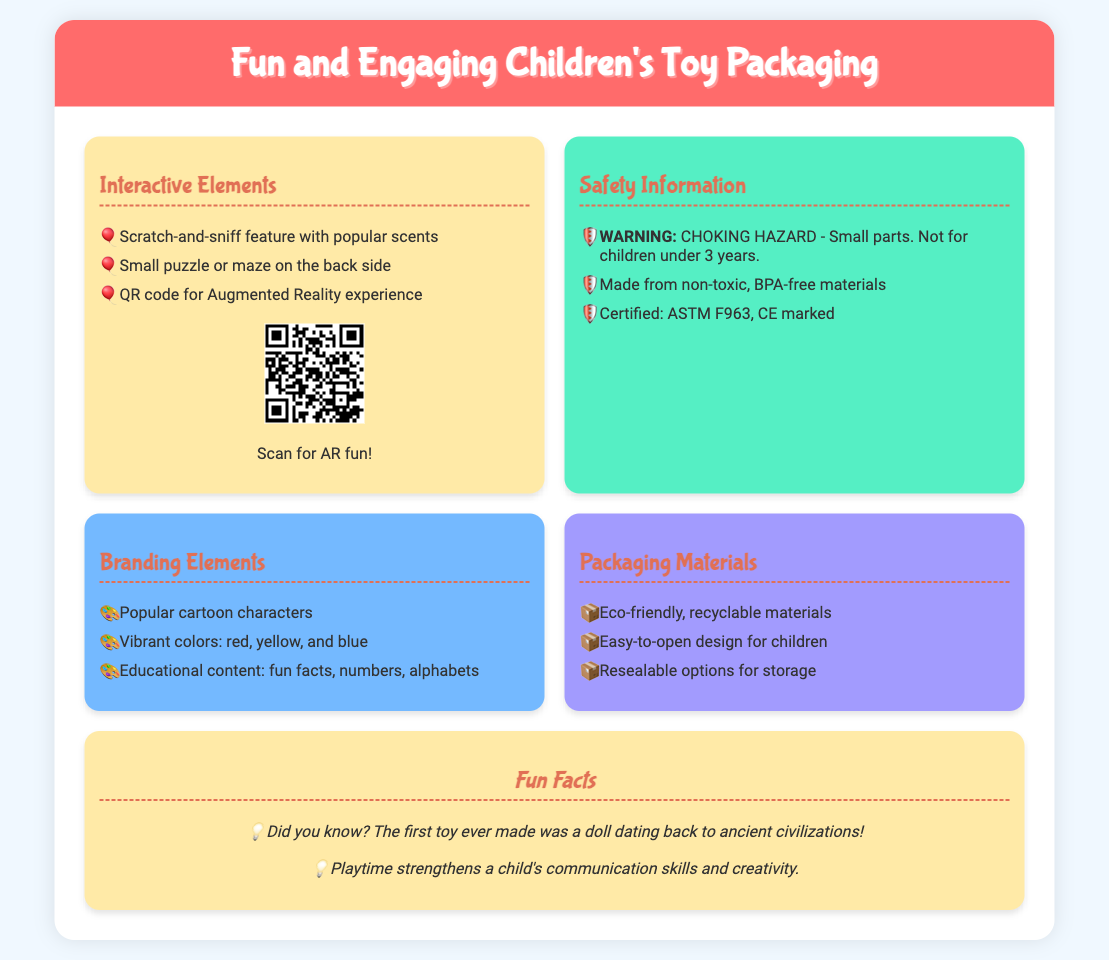What is the interactive feature that includes popular scents? The interactive feature that includes popular scents is called "Scratch-and-sniff."
Answer: Scratch-and-sniff What safety warning is listed for the toy? The safety warning listed for the toy is related to small parts, indicating a choking hazard.
Answer: CHOKING HAZARD What certification is mentioned for safety standards? The certification mentioned for safety standards is ASTM F963.
Answer: ASTM F963 What type of materials are used in the packaging? The type of materials used in the packaging are eco-friendly and recyclable.
Answer: Eco-friendly, recyclable materials What educational content is included in the branding elements? The educational content included in the branding elements consists of fun facts, numbers, and alphabets.
Answer: Fun facts, numbers, alphabets How many interactive elements are listed in the document? The document lists three interactive elements: scratch-and-sniff, puzzle or maze, and QR code.
Answer: Three How does the packaging ensure ease of use for children? The packaging ensures ease of use for children with an easy-to-open design.
Answer: Easy-to-open design What playful element is suggested for additional fun? The playful element suggested for additional fun is an Augmented Reality experience accessed through a QR code.
Answer: Augmented Reality experience What is one fun fact mentioned about playtime? One fun fact mentioned about playtime is that it strengthens a child's communication skills.
Answer: Strengthens communication skills 